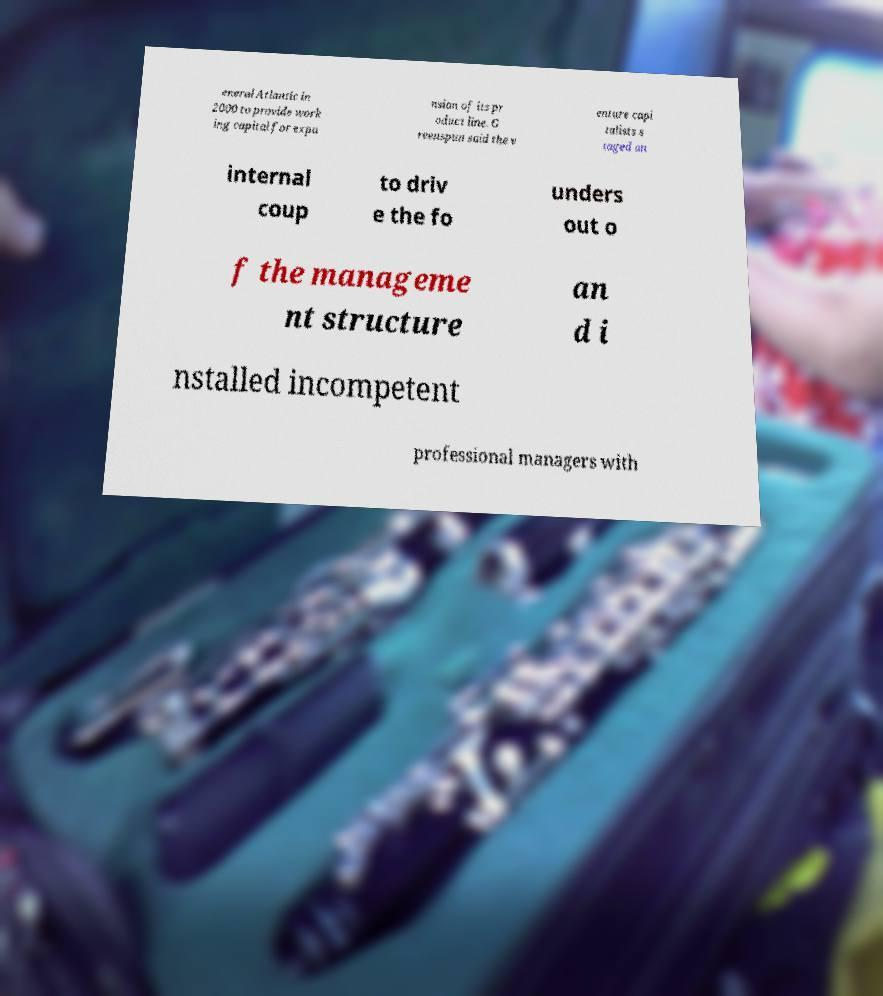Please read and relay the text visible in this image. What does it say? eneral Atlantic in 2000 to provide work ing capital for expa nsion of its pr oduct line. G reenspun said the v enture capi talists s taged an internal coup to driv e the fo unders out o f the manageme nt structure an d i nstalled incompetent professional managers with 